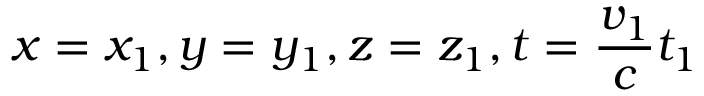Convert formula to latex. <formula><loc_0><loc_0><loc_500><loc_500>x = x _ { 1 } , y = y _ { 1 } , z = z _ { 1 } , t = \frac { v _ { 1 } } c t _ { 1 }</formula> 